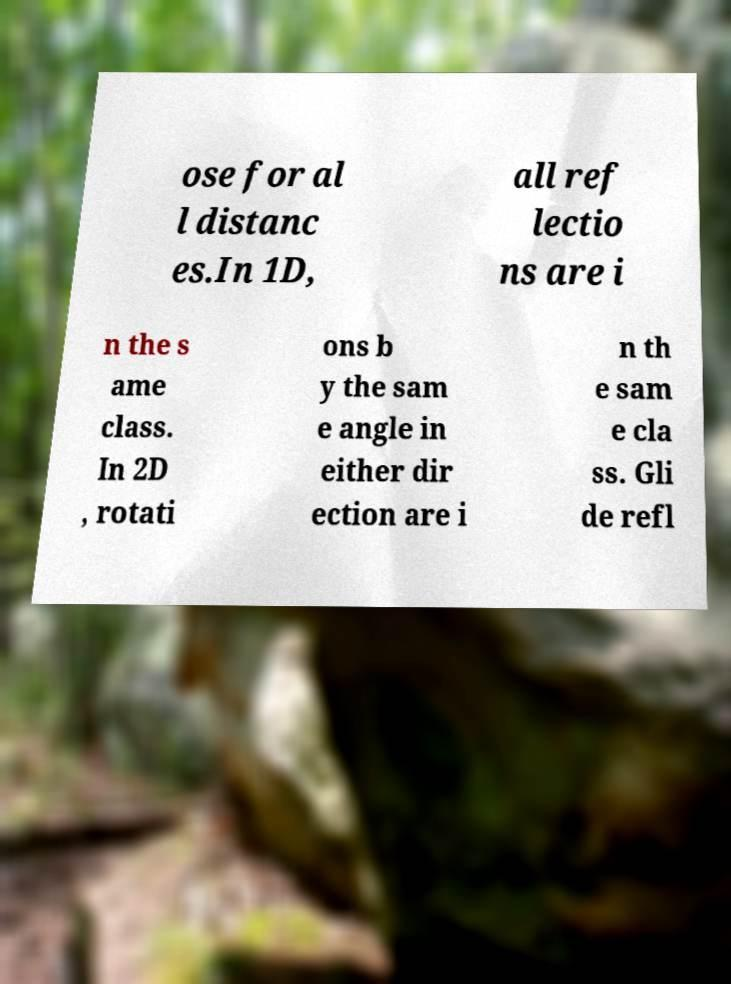Could you extract and type out the text from this image? ose for al l distanc es.In 1D, all ref lectio ns are i n the s ame class. In 2D , rotati ons b y the sam e angle in either dir ection are i n th e sam e cla ss. Gli de refl 